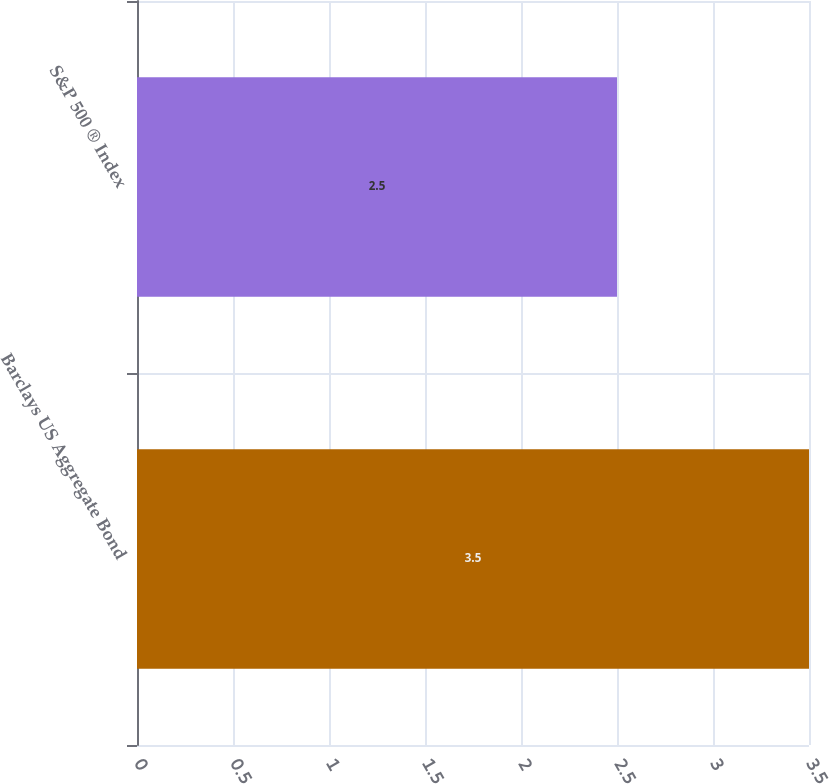<chart> <loc_0><loc_0><loc_500><loc_500><bar_chart><fcel>Barclays US Aggregate Bond<fcel>S&P 500 ® Index<nl><fcel>3.5<fcel>2.5<nl></chart> 